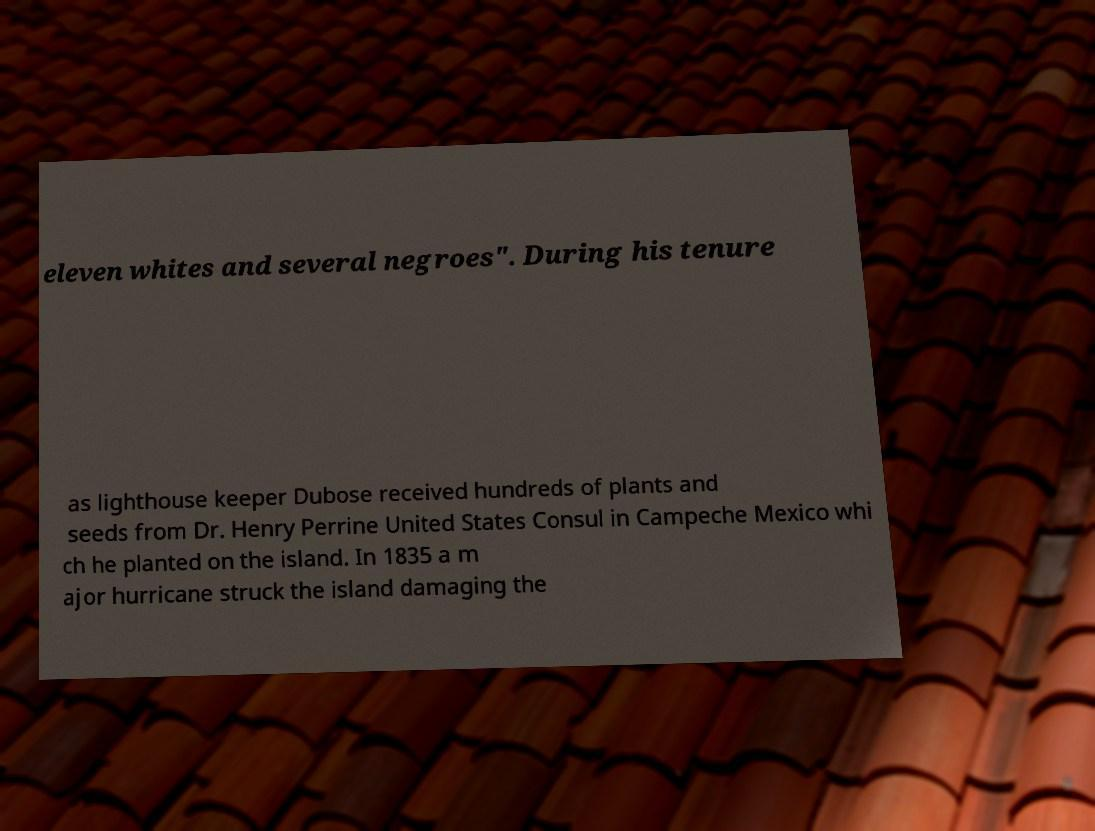There's text embedded in this image that I need extracted. Can you transcribe it verbatim? eleven whites and several negroes". During his tenure as lighthouse keeper Dubose received hundreds of plants and seeds from Dr. Henry Perrine United States Consul in Campeche Mexico whi ch he planted on the island. In 1835 a m ajor hurricane struck the island damaging the 